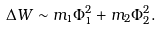<formula> <loc_0><loc_0><loc_500><loc_500>\Delta W \sim m _ { 1 } \Phi _ { 1 } ^ { 2 } + m _ { 2 } \Phi _ { 2 } ^ { 2 } .</formula> 